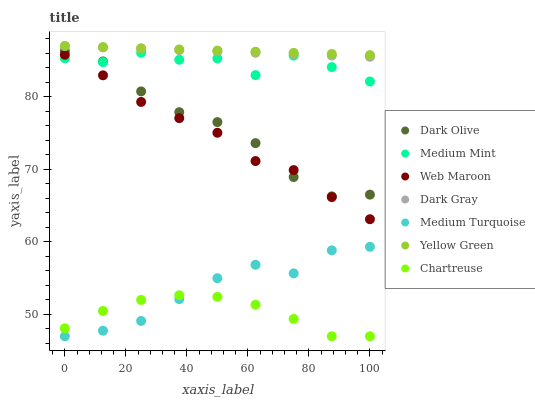Does Chartreuse have the minimum area under the curve?
Answer yes or no. Yes. Does Yellow Green have the maximum area under the curve?
Answer yes or no. Yes. Does Dark Olive have the minimum area under the curve?
Answer yes or no. No. Does Dark Olive have the maximum area under the curve?
Answer yes or no. No. Is Dark Gray the smoothest?
Answer yes or no. Yes. Is Medium Mint the roughest?
Answer yes or no. Yes. Is Yellow Green the smoothest?
Answer yes or no. No. Is Yellow Green the roughest?
Answer yes or no. No. Does Chartreuse have the lowest value?
Answer yes or no. Yes. Does Dark Olive have the lowest value?
Answer yes or no. No. Does Dark Gray have the highest value?
Answer yes or no. Yes. Does Dark Olive have the highest value?
Answer yes or no. No. Is Chartreuse less than Medium Mint?
Answer yes or no. Yes. Is Web Maroon greater than Medium Turquoise?
Answer yes or no. Yes. Does Medium Mint intersect Dark Olive?
Answer yes or no. Yes. Is Medium Mint less than Dark Olive?
Answer yes or no. No. Is Medium Mint greater than Dark Olive?
Answer yes or no. No. Does Chartreuse intersect Medium Mint?
Answer yes or no. No. 